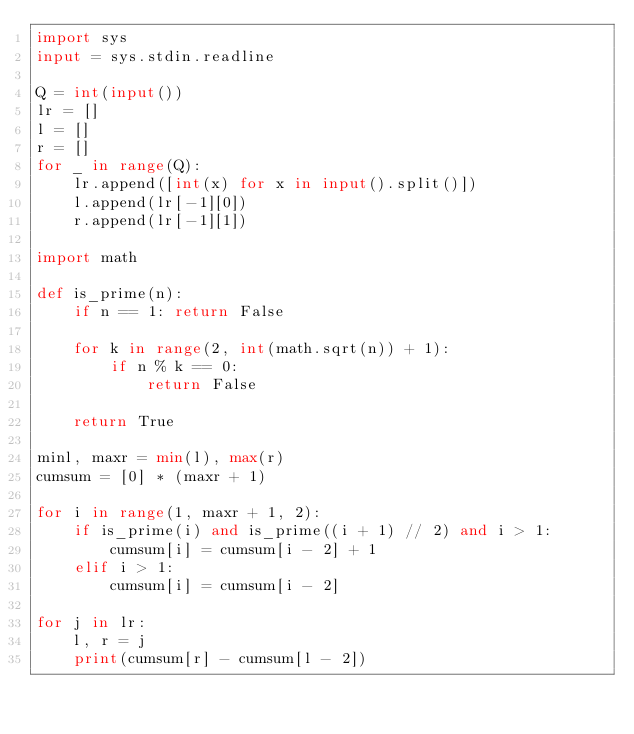<code> <loc_0><loc_0><loc_500><loc_500><_Python_>import sys
input = sys.stdin.readline

Q = int(input())
lr = []
l = []
r = []
for _ in range(Q):
    lr.append([int(x) for x in input().split()])
    l.append(lr[-1][0])
    r.append(lr[-1][1])

import math

def is_prime(n):
    if n == 1: return False

    for k in range(2, int(math.sqrt(n)) + 1):
        if n % k == 0:
            return False

    return True

minl, maxr = min(l), max(r)
cumsum = [0] * (maxr + 1)

for i in range(1, maxr + 1, 2):
    if is_prime(i) and is_prime((i + 1) // 2) and i > 1:
        cumsum[i] = cumsum[i - 2] + 1
    elif i > 1:
        cumsum[i] = cumsum[i - 2]

for j in lr:
    l, r = j
    print(cumsum[r] - cumsum[l - 2])







</code> 